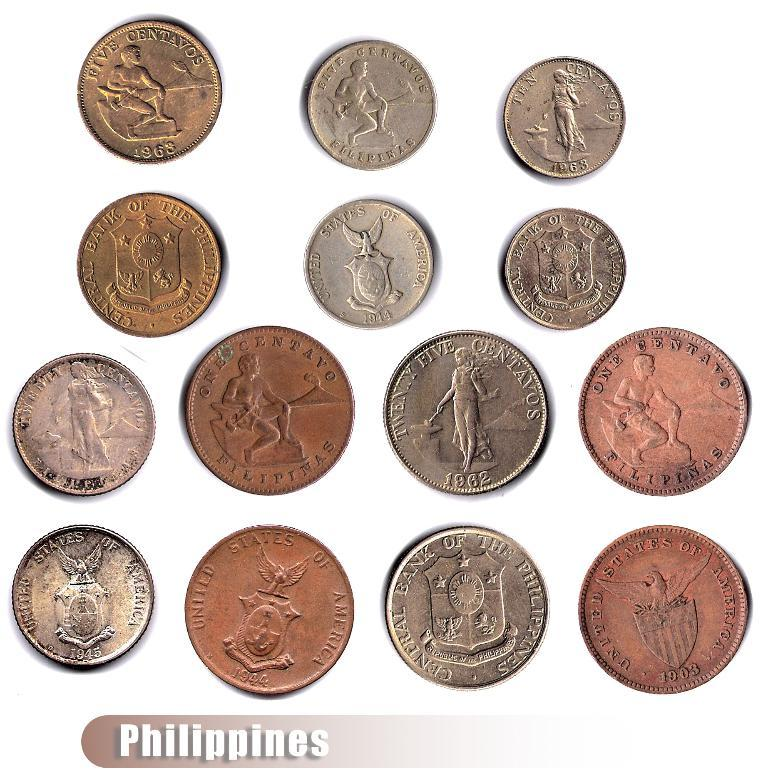Provide a one-sentence caption for the provided image. An array of different colored monetary coins from the Philippines. 